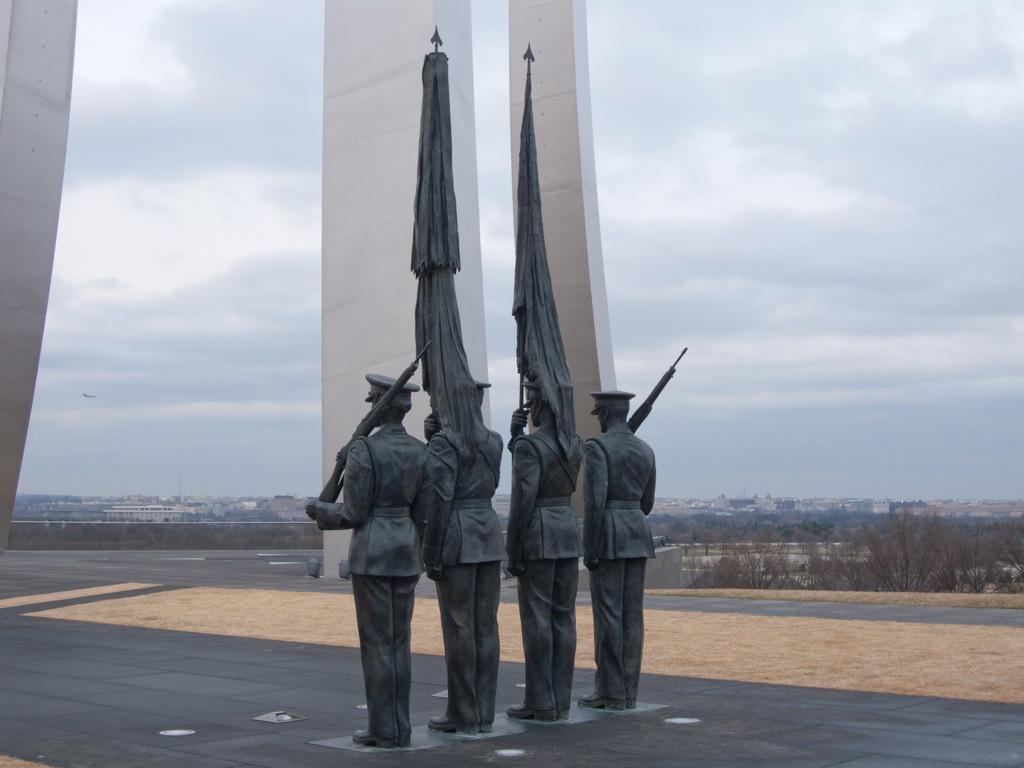Can you describe this image briefly? In the image we can see four sculptures of people standing, wearing clothes, shoes, hat and two of them are holding a rifle and the other two are holding flags in hands. Here we can see trees, buildings and the cloudy sky. Here we can see the floor and pillars. 